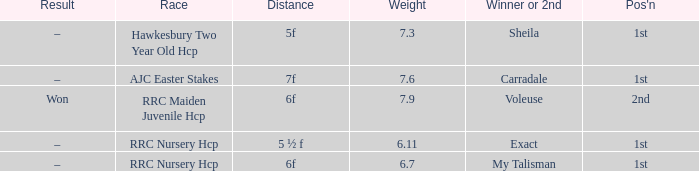Would you mind parsing the complete table? {'header': ['Result', 'Race', 'Distance', 'Weight', 'Winner or 2nd', "Pos'n"], 'rows': [['–', 'Hawkesbury Two Year Old Hcp', '5f', '7.3', 'Sheila', '1st'], ['–', 'AJC Easter Stakes', '7f', '7.6', 'Carradale', '1st'], ['Won', 'RRC Maiden Juvenile Hcp', '6f', '7.9', 'Voleuse', '2nd'], ['–', 'RRC Nursery Hcp', '5 ½ f', '6.11', 'Exact', '1st'], ['–', 'RRC Nursery Hcp', '6f', '6.7', 'My Talisman', '1st']]} What was the name of the winner or 2nd when the result was –, and weight was 6.7? My Talisman. 